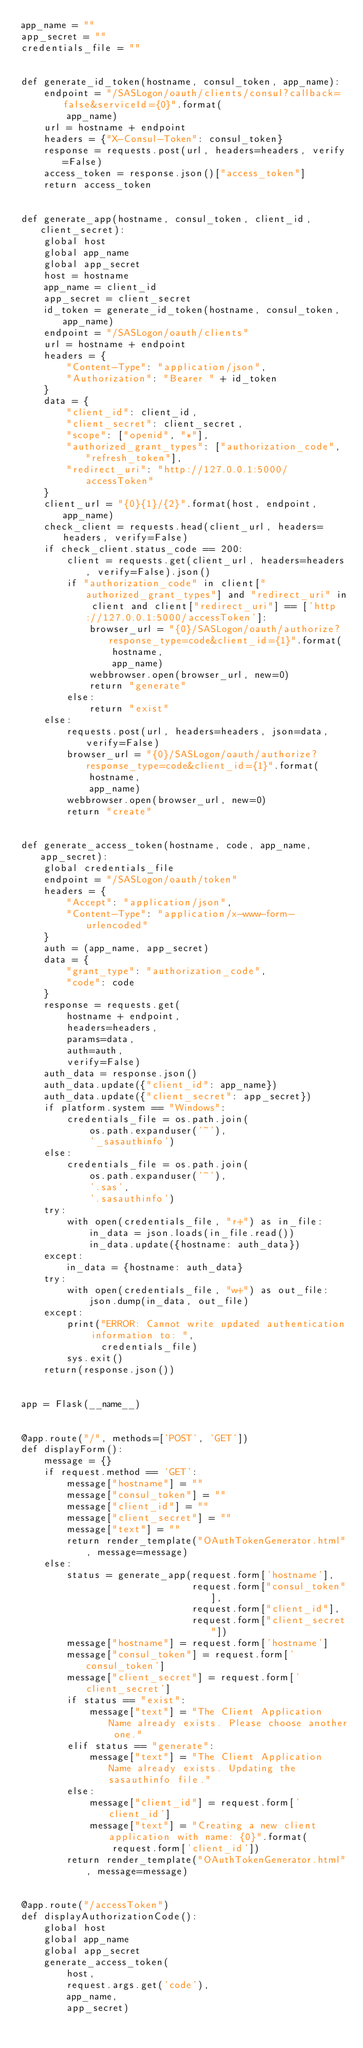Convert code to text. <code><loc_0><loc_0><loc_500><loc_500><_Python_>app_name = ""
app_secret = ""
credentials_file = ""


def generate_id_token(hostname, consul_token, app_name):
    endpoint = "/SASLogon/oauth/clients/consul?callback=false&serviceId={0}".format(
        app_name)
    url = hostname + endpoint
    headers = {"X-Consul-Token": consul_token}
    response = requests.post(url, headers=headers, verify=False)
    access_token = response.json()["access_token"]
    return access_token


def generate_app(hostname, consul_token, client_id, client_secret):
    global host
    global app_name
    global app_secret
    host = hostname
    app_name = client_id
    app_secret = client_secret
    id_token = generate_id_token(hostname, consul_token, app_name)
    endpoint = "/SASLogon/oauth/clients"
    url = hostname + endpoint
    headers = {
        "Content-Type": "application/json",
        "Authorization": "Bearer " + id_token
    }
    data = {
        "client_id": client_id,
        "client_secret": client_secret,
        "scope": ["openid", "*"],
        "authorized_grant_types": ["authorization_code", "refresh_token"],
        "redirect_uri": "http://127.0.0.1:5000/accessToken"
    }
    client_url = "{0}{1}/{2}".format(host, endpoint, app_name)
    check_client = requests.head(client_url, headers=headers, verify=False)
    if check_client.status_code == 200:
        client = requests.get(client_url, headers=headers, verify=False).json()
        if "authorization_code" in client["authorized_grant_types"] and "redirect_uri" in client and client["redirect_uri"] == ['http://127.0.0.1:5000/accessToken']:
            browser_url = "{0}/SASLogon/oauth/authorize?response_type=code&client_id={1}".format(
                hostname,
                app_name)
            webbrowser.open(browser_url, new=0)
            return "generate"
        else:
            return "exist"
    else:
        requests.post(url, headers=headers, json=data, verify=False)
        browser_url = "{0}/SASLogon/oauth/authorize?response_type=code&client_id={1}".format(
            hostname,
            app_name)
        webbrowser.open(browser_url, new=0)
        return "create"


def generate_access_token(hostname, code, app_name, app_secret):
    global credentials_file
    endpoint = "/SASLogon/oauth/token"
    headers = {
        "Accept": "application/json",
        "Content-Type": "application/x-www-form-urlencoded"
    }
    auth = (app_name, app_secret)
    data = {
        "grant_type": "authorization_code",
        "code": code
    }
    response = requests.get(
        hostname + endpoint,
        headers=headers,
        params=data,
        auth=auth,
        verify=False)
    auth_data = response.json()
    auth_data.update({"client_id": app_name})
    auth_data.update({"client_secret": app_secret})
    if platform.system == "Windows":
        credentials_file = os.path.join(
            os.path.expanduser('~'),
            '_sasauthinfo')
    else:
        credentials_file = os.path.join(
            os.path.expanduser('~'),
            '.sas',
            '.sasauthinfo')
    try:
        with open(credentials_file, "r+") as in_file:
            in_data = json.loads(in_file.read())
            in_data.update({hostname: auth_data})
    except:
        in_data = {hostname: auth_data}
    try:
        with open(credentials_file, "w+") as out_file:
            json.dump(in_data, out_file)
    except:
        print("ERROR: Cannot write updated authentication information to: ",
              credentials_file)
        sys.exit()
    return(response.json())


app = Flask(__name__)


@app.route("/", methods=['POST', 'GET'])
def displayForm():
    message = {}
    if request.method == 'GET':
        message["hostname"] = ""
        message["consul_token"] = ""
        message["client_id"] = ""
        message["client_secret"] = ""
        message["text"] = ""
        return render_template("OAuthTokenGenerator.html", message=message)
    else:
        status = generate_app(request.form['hostname'],
                              request.form["consul_token"],
                              request.form["client_id"],
                              request.form["client_secret"])
        message["hostname"] = request.form['hostname']
        message["consul_token"] = request.form['consul_token']
        message["client_secret"] = request.form['client_secret']
        if status == "exist":
            message["text"] = "The Client Application Name already exists. Please choose another one."
        elif status == "generate":
            message["text"] = "The Client Application Name already exists. Updating the sasauthinfo file."
        else:
            message["client_id"] = request.form['client_id']
            message["text"] = "Creating a new client application with name: {0}".format(
                request.form['client_id'])
        return render_template("OAuthTokenGenerator.html", message=message)


@app.route("/accessToken")
def displayAuthorizationCode():
    global host
    global app_name
    global app_secret
    generate_access_token(
        host,
        request.args.get('code'),
        app_name,
        app_secret)</code> 